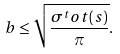Convert formula to latex. <formula><loc_0><loc_0><loc_500><loc_500>b \leq \sqrt { \frac { \sigma ^ { t } o t ( s ) } { \pi } } .</formula> 